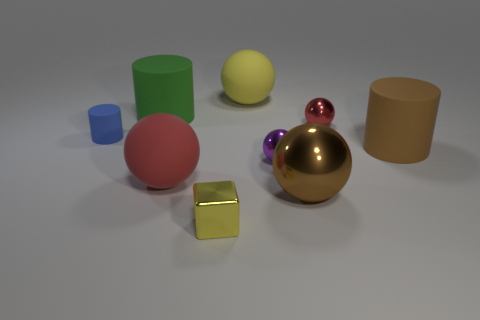Subtract 1 balls. How many balls are left? 4 Subtract all purple spheres. How many spheres are left? 4 Subtract all red shiny balls. How many balls are left? 4 Subtract all gray balls. Subtract all brown cylinders. How many balls are left? 5 Add 1 big red matte balls. How many objects exist? 10 Subtract all cylinders. How many objects are left? 6 Subtract all green cylinders. Subtract all purple shiny balls. How many objects are left? 7 Add 6 big spheres. How many big spheres are left? 9 Add 6 tiny cyan metallic balls. How many tiny cyan metallic balls exist? 6 Subtract 0 blue spheres. How many objects are left? 9 